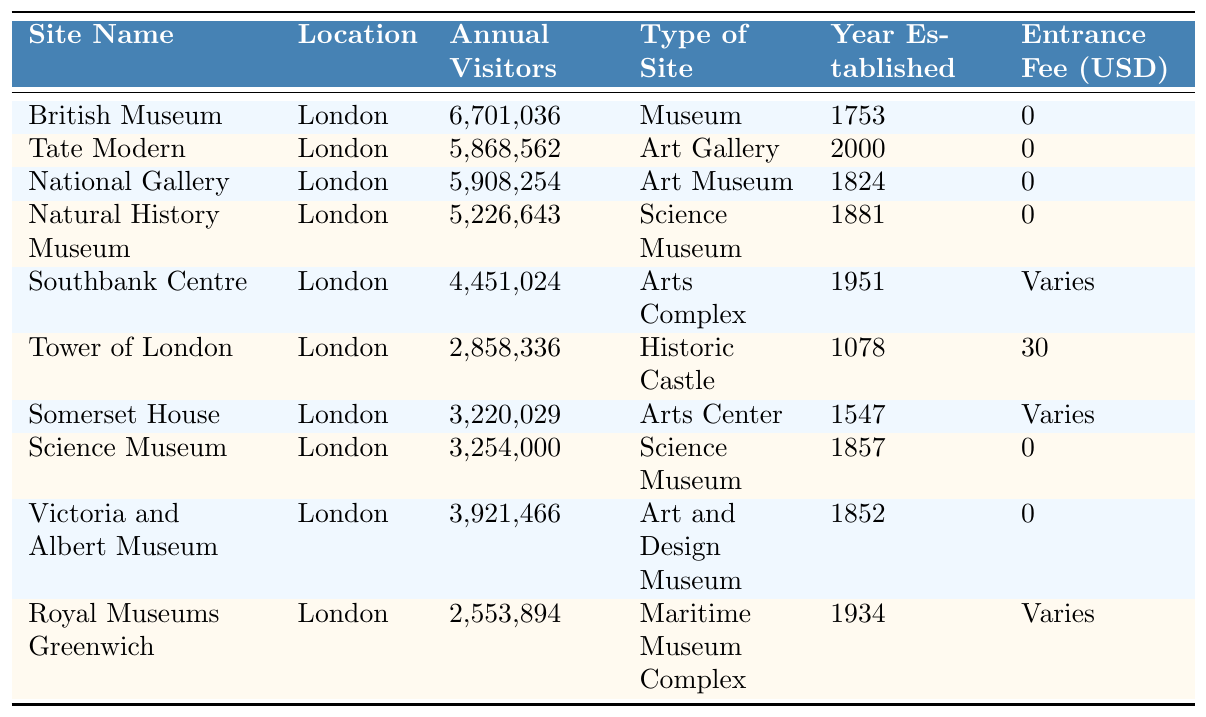What is the most visited cultural site listed in the table? The table shows the annual visitors for each site. The British Museum has the highest count with 6,701,036 visitors.
Answer: British Museum How many visitors did the Tower of London receive annually? The table lists the Tower of London with an annual visitor count of 2,858,336.
Answer: 2,858,336 Which site has an entrance fee of 30 USD? By looking at the entrance fees, the Tower of London is the only site with a listed fee of 30 USD.
Answer: Tower of London What type of site is the Tate Modern? The table specifies that the Tate Modern is categorized as an Art Gallery.
Answer: Art Gallery What is the total number of annual visitors for the top three sites? The annual visitors for the top three sites are: British Museum (6,701,036), National Gallery (5,908,254), and Tate Modern (5,868,562). Summing these gives 6,701,036 + 5,908,254 + 5,868,562 = 18,477,852.
Answer: 18,477,852 What is the average number of annual visitors across all sites listed? To find the average, we add the annual visitors for all 10 sites: 6,701,036 + 5,868,562 + 5,908,254 + 5,226,643 + 4,451,024 + 2,858,336 + 3,220,029 + 3,254,000 + 3,921,466 + 2,553,894 = 43,770,234. Dividing that total by 10 gives an average of 4,377,023.4.
Answer: 4,377,023 Are all sites located in London? The table shows all sites listed have London as their location.
Answer: Yes Which types of sites have no entrance fee? The types of sites listed without an entrance fee are Museum, Art Gallery, Art Museum, Science Museum, and Art and Design Museum. This is determined by checking the entrance fees where the amount is noted as 0.
Answer: Museum, Art Gallery, Art Museum, Science Museum, Art and Design Museum How many science museums are listed in the table? The table indicates there are two science museums: the Natural History Museum and the Science Museum.
Answer: 2 Which site was established first, the Tower of London or the Victoria and Albert Museum? Looking at the year established, the Tower of London was established in 1078 while the Victoria and Albert Museum was established in 1852, making the Tower of London the older site.
Answer: Tower of London What is the difference in annual visitors between the British Museum and the Royal Museums Greenwich? The British Museum has 6,701,036 visitors while the Royal Museums Greenwich has 2,553,894 visitors. The difference is 6,701,036 - 2,553,894 = 4,147,142.
Answer: 4,147,142 